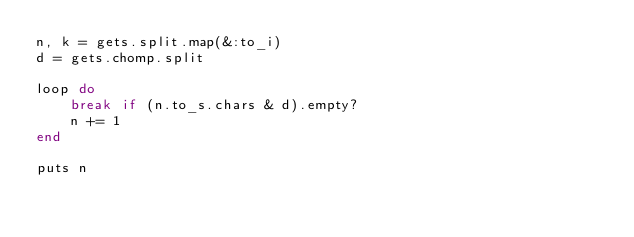Convert code to text. <code><loc_0><loc_0><loc_500><loc_500><_Ruby_>n, k = gets.split.map(&:to_i)
d = gets.chomp.split

loop do
    break if (n.to_s.chars & d).empty?
    n += 1
end

puts n</code> 